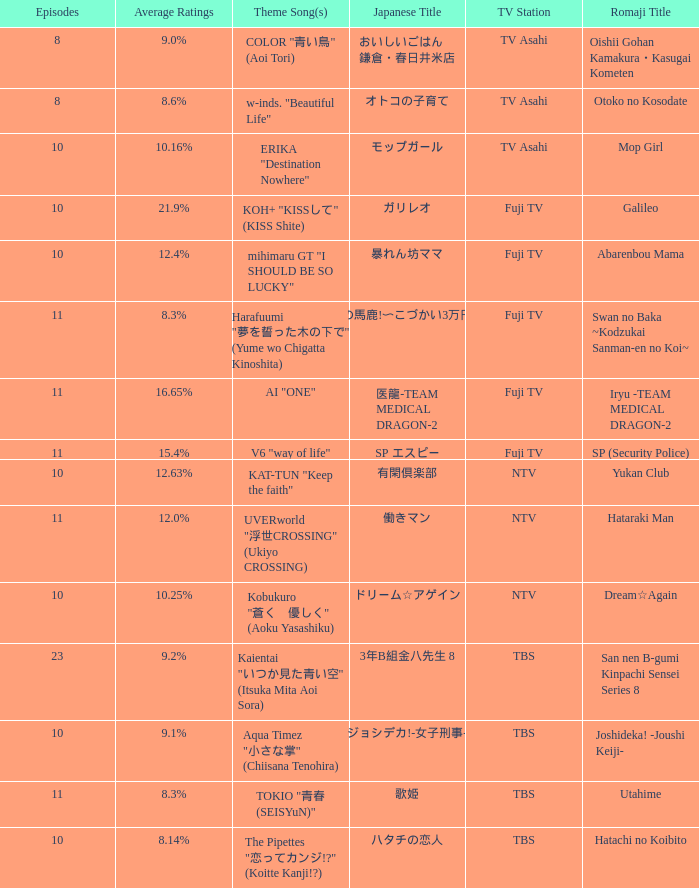What is the main theme song for 働きマン? UVERworld "浮世CROSSING" (Ukiyo CROSSING). 